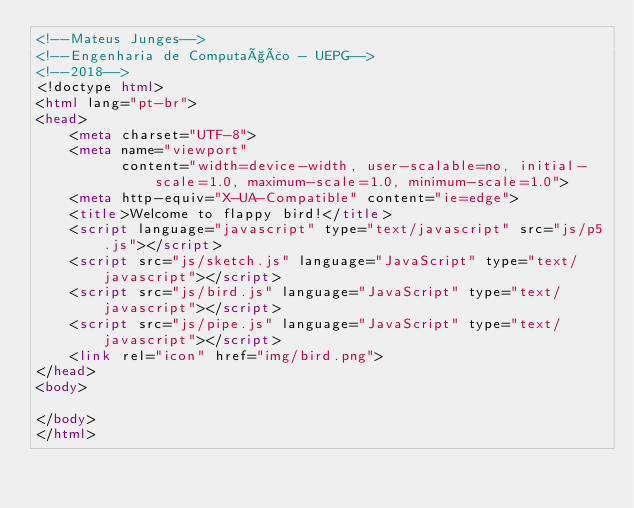<code> <loc_0><loc_0><loc_500><loc_500><_HTML_><!--Mateus Junges-->
<!--Engenharia de Computação - UEPG-->
<!--2018-->
<!doctype html>
<html lang="pt-br">
<head>
    <meta charset="UTF-8">
    <meta name="viewport"
          content="width=device-width, user-scalable=no, initial-scale=1.0, maximum-scale=1.0, minimum-scale=1.0">
    <meta http-equiv="X-UA-Compatible" content="ie=edge">
    <title>Welcome to flappy bird!</title>
    <script language="javascript" type="text/javascript" src="js/p5.js"></script>
    <script src="js/sketch.js" language="JavaScript" type="text/javascript"></script>
    <script src="js/bird.js" language="JavaScript" type="text/javascript"></script>
    <script src="js/pipe.js" language="JavaScript" type="text/javascript"></script>
    <link rel="icon" href="img/bird.png">
</head>
<body>

</body>
</html></code> 